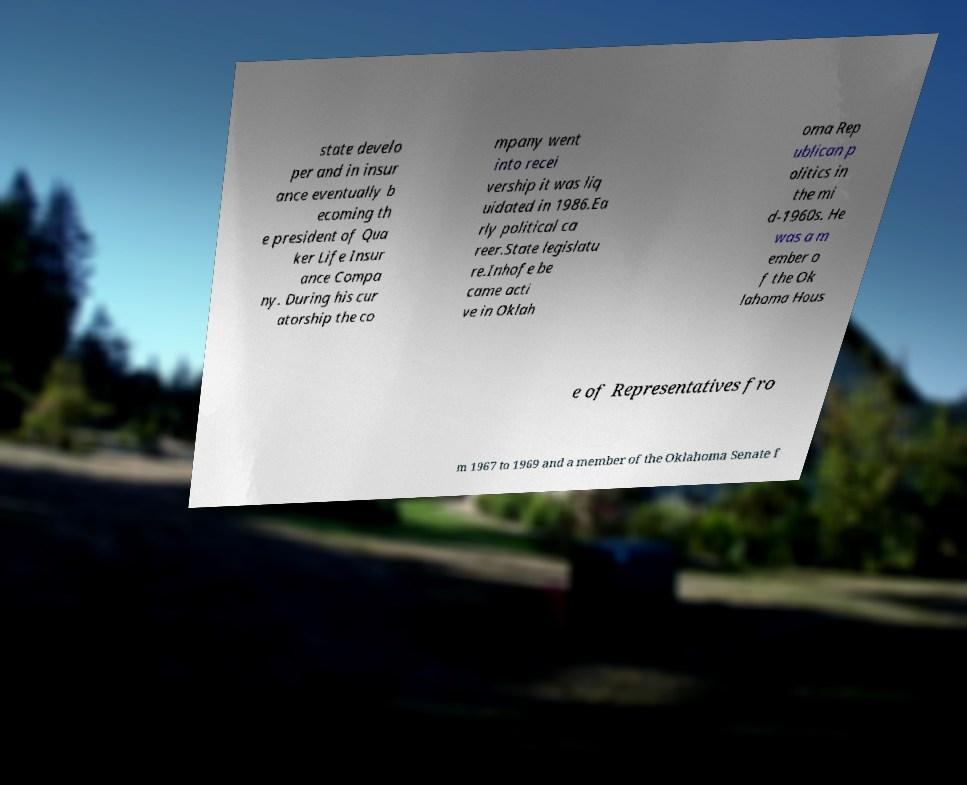Can you accurately transcribe the text from the provided image for me? state develo per and in insur ance eventually b ecoming th e president of Qua ker Life Insur ance Compa ny. During his cur atorship the co mpany went into recei vership it was liq uidated in 1986.Ea rly political ca reer.State legislatu re.Inhofe be came acti ve in Oklah oma Rep ublican p olitics in the mi d-1960s. He was a m ember o f the Ok lahoma Hous e of Representatives fro m 1967 to 1969 and a member of the Oklahoma Senate f 